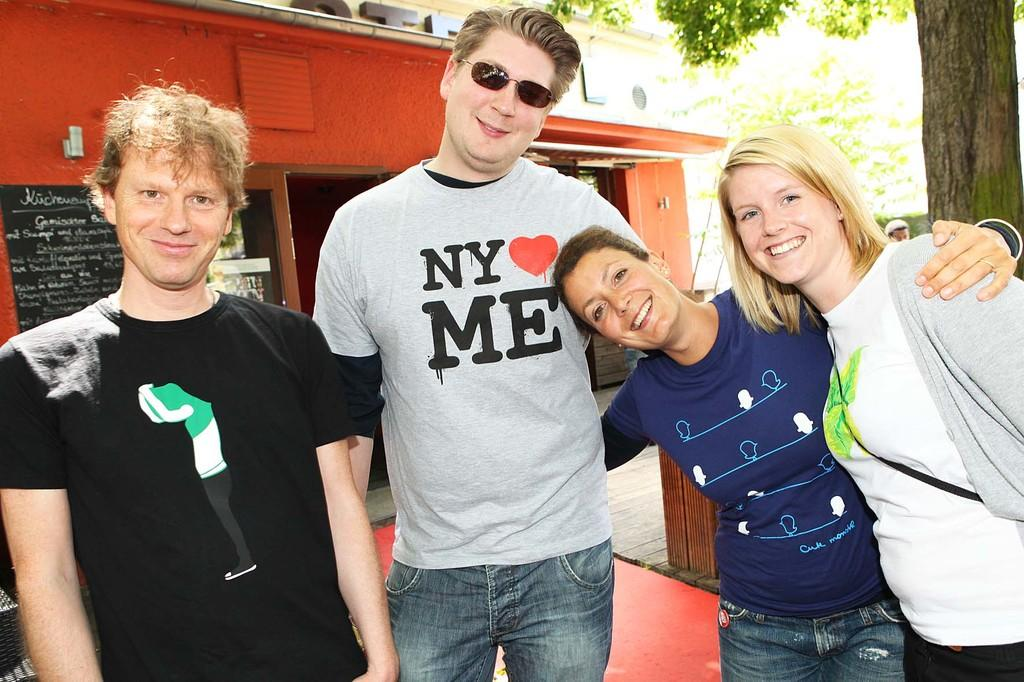How many people are present in the image? There are four people in the image. What is the facial expression of the people in the image? The people are smiling. What can be seen in the background of the image? There is a house, a name board, posters, a person, and trees in the background of the image. What type of bread is being served at the writer's tent in the image? There is no writer or tent present in the image, and therefore no such activity or setting can be observed. 